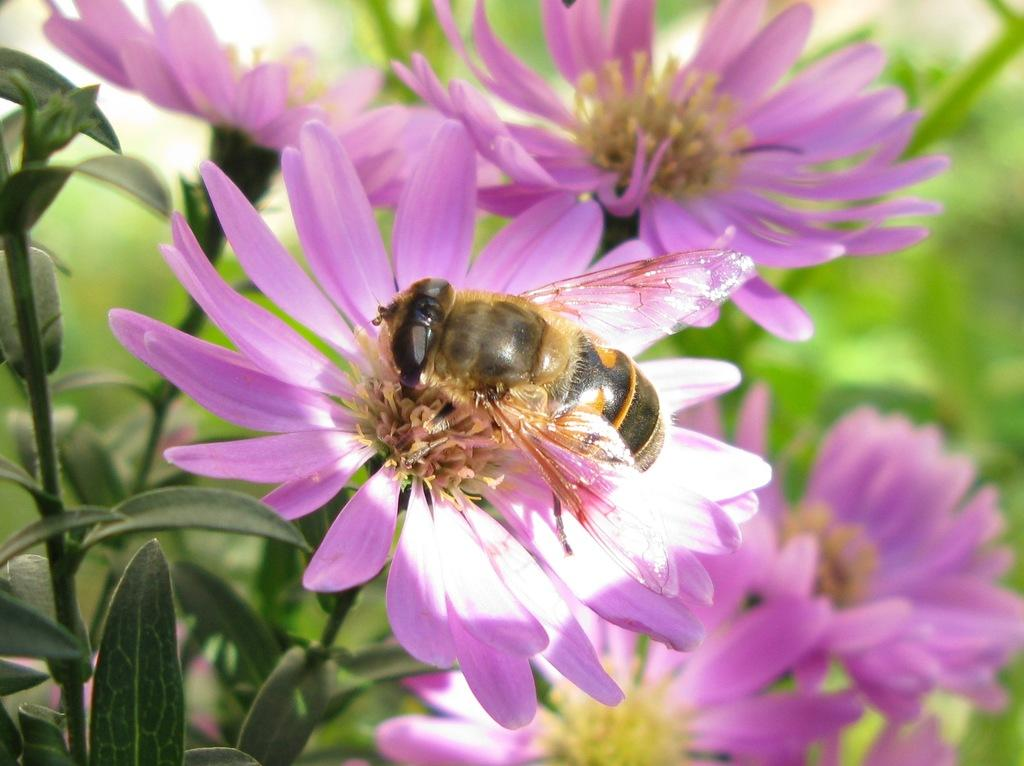What type of insect is present in the image? There is a honeybee in the image. What can be seen in the background of the image? There are plants with flowers in the background of the image. Can you describe the goldfish swimming in the scene in the image? There is no goldfish present in the image; it features a honeybee and plants with flowers. 